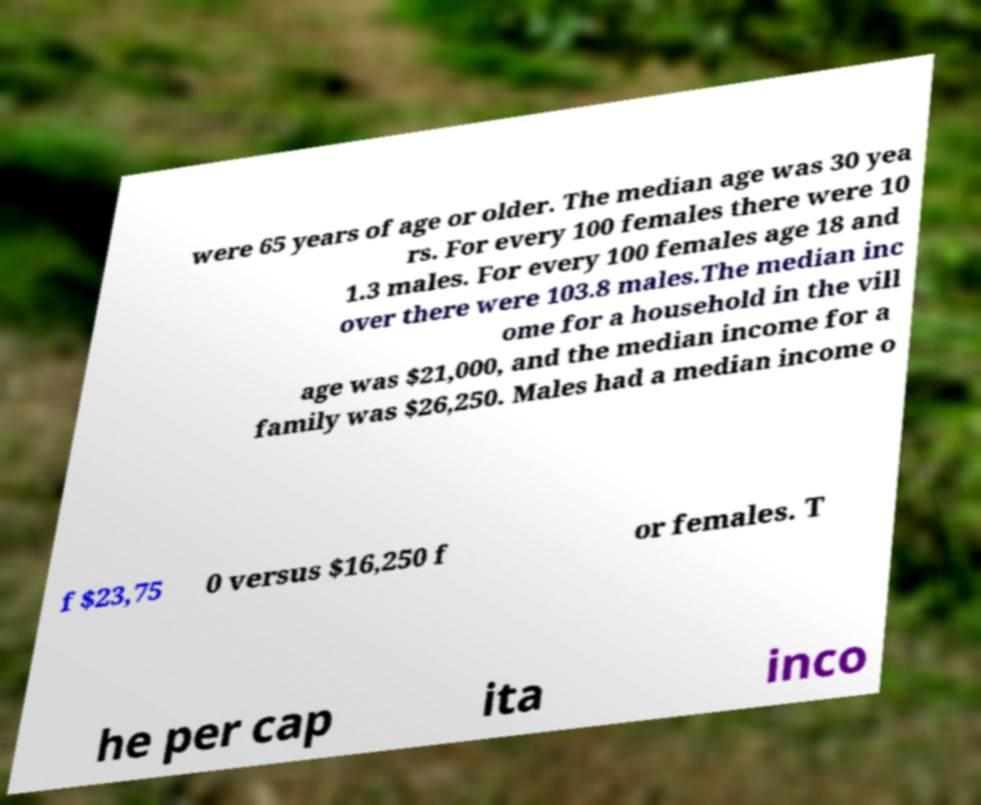Could you extract and type out the text from this image? were 65 years of age or older. The median age was 30 yea rs. For every 100 females there were 10 1.3 males. For every 100 females age 18 and over there were 103.8 males.The median inc ome for a household in the vill age was $21,000, and the median income for a family was $26,250. Males had a median income o f $23,75 0 versus $16,250 f or females. T he per cap ita inco 